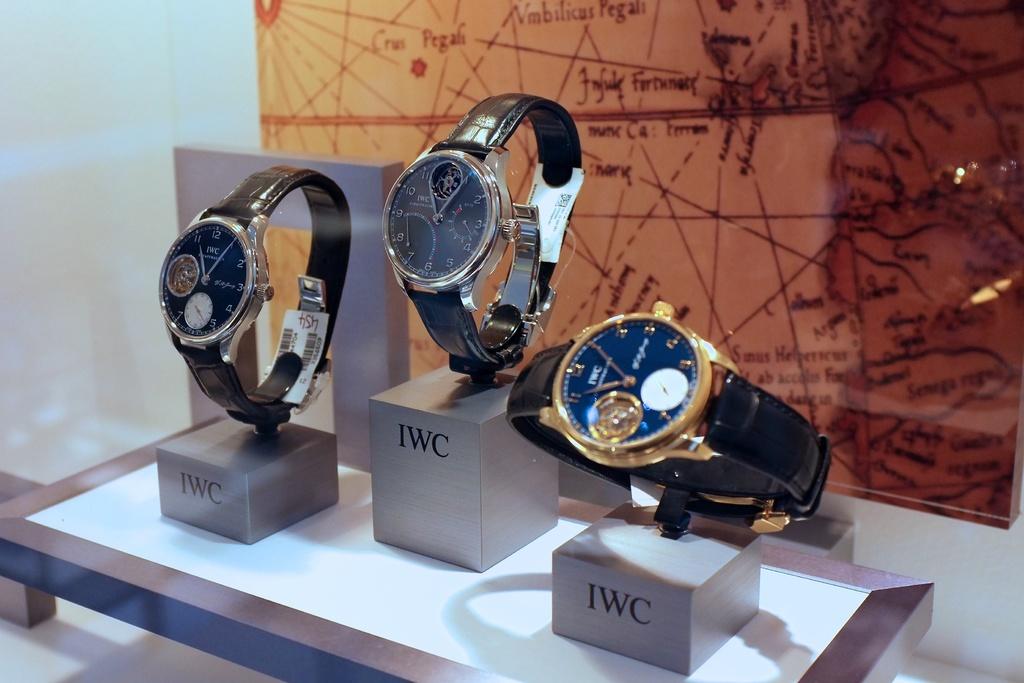How much is the watch?
Offer a terse response. 454. 